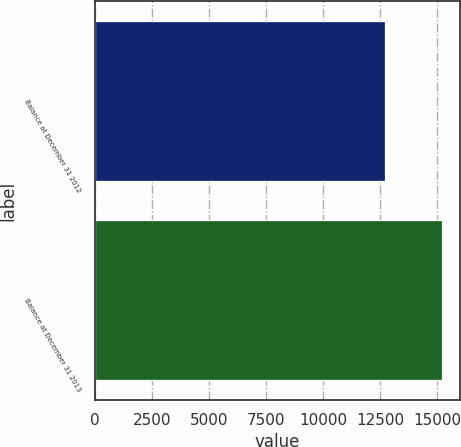Convert chart. <chart><loc_0><loc_0><loc_500><loc_500><bar_chart><fcel>Balance at December 31 2012<fcel>Balance at December 31 2013<nl><fcel>12720<fcel>15221<nl></chart> 